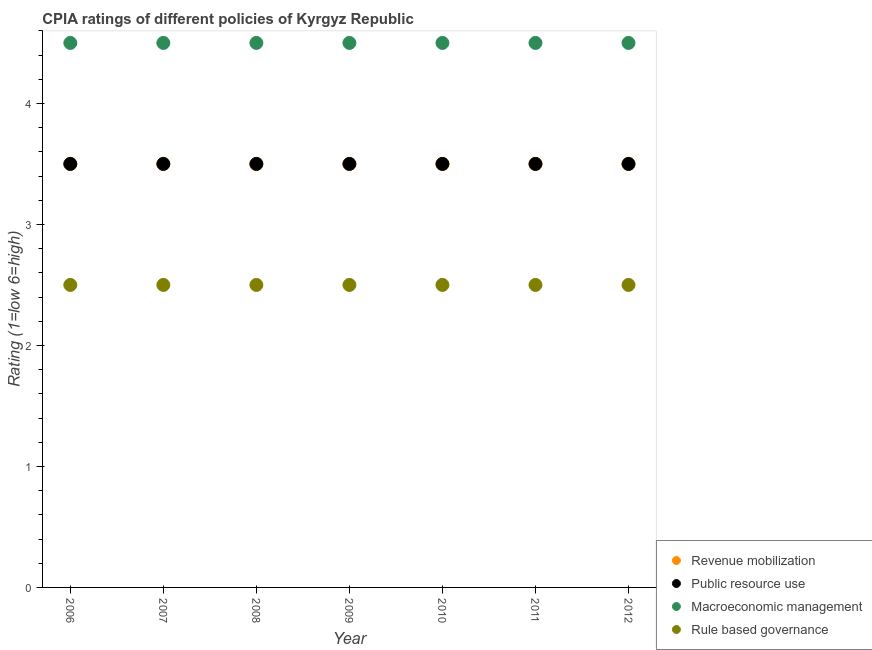How many different coloured dotlines are there?
Provide a short and direct response. 4. Is the number of dotlines equal to the number of legend labels?
Make the answer very short. Yes. Across all years, what is the maximum cpia rating of public resource use?
Offer a very short reply. 3.5. In which year was the cpia rating of public resource use minimum?
Your response must be concise. 2006. What is the total cpia rating of public resource use in the graph?
Keep it short and to the point. 24.5. What is the difference between the cpia rating of macroeconomic management in 2011 and that in 2012?
Provide a succinct answer. 0. What is the average cpia rating of macroeconomic management per year?
Keep it short and to the point. 4.5. In the year 2011, what is the difference between the cpia rating of public resource use and cpia rating of rule based governance?
Provide a succinct answer. 1. What is the ratio of the cpia rating of macroeconomic management in 2006 to that in 2011?
Provide a succinct answer. 1. Is the cpia rating of macroeconomic management in 2011 less than that in 2012?
Offer a very short reply. No. Is the sum of the cpia rating of revenue mobilization in 2008 and 2009 greater than the maximum cpia rating of macroeconomic management across all years?
Keep it short and to the point. Yes. Does the cpia rating of macroeconomic management monotonically increase over the years?
Your answer should be compact. No. Is the cpia rating of macroeconomic management strictly greater than the cpia rating of rule based governance over the years?
Give a very brief answer. Yes. Is the cpia rating of rule based governance strictly less than the cpia rating of revenue mobilization over the years?
Ensure brevity in your answer.  Yes. Are the values on the major ticks of Y-axis written in scientific E-notation?
Your response must be concise. No. Does the graph contain grids?
Your answer should be very brief. No. Where does the legend appear in the graph?
Provide a short and direct response. Bottom right. How many legend labels are there?
Offer a very short reply. 4. How are the legend labels stacked?
Give a very brief answer. Vertical. What is the title of the graph?
Offer a very short reply. CPIA ratings of different policies of Kyrgyz Republic. What is the Rating (1=low 6=high) of Revenue mobilization in 2006?
Your answer should be very brief. 3.5. What is the Rating (1=low 6=high) in Public resource use in 2006?
Offer a terse response. 3.5. What is the Rating (1=low 6=high) of Macroeconomic management in 2006?
Provide a short and direct response. 4.5. What is the Rating (1=low 6=high) in Revenue mobilization in 2007?
Offer a very short reply. 3.5. What is the Rating (1=low 6=high) of Public resource use in 2007?
Give a very brief answer. 3.5. What is the Rating (1=low 6=high) of Macroeconomic management in 2007?
Your answer should be compact. 4.5. What is the Rating (1=low 6=high) of Revenue mobilization in 2008?
Your answer should be compact. 3.5. What is the Rating (1=low 6=high) of Macroeconomic management in 2008?
Ensure brevity in your answer.  4.5. What is the Rating (1=low 6=high) in Public resource use in 2009?
Offer a very short reply. 3.5. What is the Rating (1=low 6=high) of Macroeconomic management in 2009?
Keep it short and to the point. 4.5. What is the Rating (1=low 6=high) of Public resource use in 2010?
Give a very brief answer. 3.5. What is the Rating (1=low 6=high) of Macroeconomic management in 2010?
Make the answer very short. 4.5. What is the Rating (1=low 6=high) in Revenue mobilization in 2011?
Ensure brevity in your answer.  3.5. What is the Rating (1=low 6=high) of Public resource use in 2011?
Make the answer very short. 3.5. What is the Rating (1=low 6=high) of Rule based governance in 2011?
Ensure brevity in your answer.  2.5. What is the Rating (1=low 6=high) of Revenue mobilization in 2012?
Ensure brevity in your answer.  3.5. What is the Rating (1=low 6=high) of Macroeconomic management in 2012?
Keep it short and to the point. 4.5. Across all years, what is the maximum Rating (1=low 6=high) of Revenue mobilization?
Offer a very short reply. 3.5. Across all years, what is the maximum Rating (1=low 6=high) in Macroeconomic management?
Offer a very short reply. 4.5. Across all years, what is the minimum Rating (1=low 6=high) of Revenue mobilization?
Your response must be concise. 3.5. Across all years, what is the minimum Rating (1=low 6=high) of Public resource use?
Your response must be concise. 3.5. What is the total Rating (1=low 6=high) of Revenue mobilization in the graph?
Provide a succinct answer. 24.5. What is the total Rating (1=low 6=high) of Public resource use in the graph?
Ensure brevity in your answer.  24.5. What is the total Rating (1=low 6=high) of Macroeconomic management in the graph?
Offer a terse response. 31.5. What is the difference between the Rating (1=low 6=high) of Macroeconomic management in 2006 and that in 2007?
Offer a terse response. 0. What is the difference between the Rating (1=low 6=high) in Revenue mobilization in 2006 and that in 2008?
Your response must be concise. 0. What is the difference between the Rating (1=low 6=high) of Public resource use in 2006 and that in 2008?
Your response must be concise. 0. What is the difference between the Rating (1=low 6=high) of Macroeconomic management in 2006 and that in 2008?
Provide a succinct answer. 0. What is the difference between the Rating (1=low 6=high) of Revenue mobilization in 2006 and that in 2009?
Your answer should be very brief. 0. What is the difference between the Rating (1=low 6=high) of Macroeconomic management in 2006 and that in 2009?
Make the answer very short. 0. What is the difference between the Rating (1=low 6=high) in Rule based governance in 2006 and that in 2009?
Offer a very short reply. 0. What is the difference between the Rating (1=low 6=high) of Macroeconomic management in 2006 and that in 2010?
Make the answer very short. 0. What is the difference between the Rating (1=low 6=high) of Rule based governance in 2006 and that in 2010?
Your response must be concise. 0. What is the difference between the Rating (1=low 6=high) of Revenue mobilization in 2006 and that in 2011?
Offer a very short reply. 0. What is the difference between the Rating (1=low 6=high) of Public resource use in 2006 and that in 2011?
Offer a very short reply. 0. What is the difference between the Rating (1=low 6=high) of Macroeconomic management in 2006 and that in 2011?
Make the answer very short. 0. What is the difference between the Rating (1=low 6=high) of Rule based governance in 2006 and that in 2011?
Your answer should be very brief. 0. What is the difference between the Rating (1=low 6=high) in Revenue mobilization in 2006 and that in 2012?
Your answer should be compact. 0. What is the difference between the Rating (1=low 6=high) in Macroeconomic management in 2006 and that in 2012?
Your answer should be compact. 0. What is the difference between the Rating (1=low 6=high) in Rule based governance in 2006 and that in 2012?
Offer a very short reply. 0. What is the difference between the Rating (1=low 6=high) of Public resource use in 2007 and that in 2008?
Your answer should be very brief. 0. What is the difference between the Rating (1=low 6=high) in Macroeconomic management in 2007 and that in 2008?
Your answer should be very brief. 0. What is the difference between the Rating (1=low 6=high) in Rule based governance in 2007 and that in 2008?
Your answer should be very brief. 0. What is the difference between the Rating (1=low 6=high) of Revenue mobilization in 2007 and that in 2009?
Provide a succinct answer. 0. What is the difference between the Rating (1=low 6=high) of Macroeconomic management in 2007 and that in 2009?
Offer a terse response. 0. What is the difference between the Rating (1=low 6=high) of Macroeconomic management in 2007 and that in 2010?
Your response must be concise. 0. What is the difference between the Rating (1=low 6=high) in Rule based governance in 2007 and that in 2010?
Provide a succinct answer. 0. What is the difference between the Rating (1=low 6=high) in Revenue mobilization in 2007 and that in 2011?
Offer a very short reply. 0. What is the difference between the Rating (1=low 6=high) in Rule based governance in 2007 and that in 2011?
Your answer should be compact. 0. What is the difference between the Rating (1=low 6=high) in Rule based governance in 2007 and that in 2012?
Give a very brief answer. 0. What is the difference between the Rating (1=low 6=high) of Revenue mobilization in 2008 and that in 2009?
Offer a terse response. 0. What is the difference between the Rating (1=low 6=high) of Macroeconomic management in 2008 and that in 2009?
Your response must be concise. 0. What is the difference between the Rating (1=low 6=high) of Public resource use in 2008 and that in 2010?
Make the answer very short. 0. What is the difference between the Rating (1=low 6=high) of Revenue mobilization in 2008 and that in 2011?
Offer a terse response. 0. What is the difference between the Rating (1=low 6=high) of Rule based governance in 2008 and that in 2011?
Provide a short and direct response. 0. What is the difference between the Rating (1=low 6=high) in Revenue mobilization in 2008 and that in 2012?
Offer a very short reply. 0. What is the difference between the Rating (1=low 6=high) of Public resource use in 2008 and that in 2012?
Provide a succinct answer. 0. What is the difference between the Rating (1=low 6=high) in Macroeconomic management in 2008 and that in 2012?
Ensure brevity in your answer.  0. What is the difference between the Rating (1=low 6=high) in Rule based governance in 2008 and that in 2012?
Offer a very short reply. 0. What is the difference between the Rating (1=low 6=high) of Revenue mobilization in 2009 and that in 2011?
Offer a terse response. 0. What is the difference between the Rating (1=low 6=high) of Public resource use in 2009 and that in 2011?
Provide a short and direct response. 0. What is the difference between the Rating (1=low 6=high) of Rule based governance in 2009 and that in 2011?
Your answer should be very brief. 0. What is the difference between the Rating (1=low 6=high) in Public resource use in 2009 and that in 2012?
Your answer should be compact. 0. What is the difference between the Rating (1=low 6=high) in Rule based governance in 2009 and that in 2012?
Give a very brief answer. 0. What is the difference between the Rating (1=low 6=high) in Revenue mobilization in 2010 and that in 2011?
Ensure brevity in your answer.  0. What is the difference between the Rating (1=low 6=high) in Public resource use in 2010 and that in 2011?
Provide a short and direct response. 0. What is the difference between the Rating (1=low 6=high) of Rule based governance in 2010 and that in 2011?
Provide a succinct answer. 0. What is the difference between the Rating (1=low 6=high) in Revenue mobilization in 2010 and that in 2012?
Offer a very short reply. 0. What is the difference between the Rating (1=low 6=high) in Public resource use in 2010 and that in 2012?
Offer a terse response. 0. What is the difference between the Rating (1=low 6=high) in Macroeconomic management in 2010 and that in 2012?
Keep it short and to the point. 0. What is the difference between the Rating (1=low 6=high) of Revenue mobilization in 2011 and that in 2012?
Offer a very short reply. 0. What is the difference between the Rating (1=low 6=high) of Public resource use in 2011 and that in 2012?
Your answer should be compact. 0. What is the difference between the Rating (1=low 6=high) in Rule based governance in 2011 and that in 2012?
Your answer should be compact. 0. What is the difference between the Rating (1=low 6=high) of Revenue mobilization in 2006 and the Rating (1=low 6=high) of Public resource use in 2007?
Provide a short and direct response. 0. What is the difference between the Rating (1=low 6=high) in Revenue mobilization in 2006 and the Rating (1=low 6=high) in Macroeconomic management in 2007?
Keep it short and to the point. -1. What is the difference between the Rating (1=low 6=high) of Public resource use in 2006 and the Rating (1=low 6=high) of Rule based governance in 2007?
Your answer should be compact. 1. What is the difference between the Rating (1=low 6=high) of Revenue mobilization in 2006 and the Rating (1=low 6=high) of Public resource use in 2008?
Your answer should be compact. 0. What is the difference between the Rating (1=low 6=high) of Revenue mobilization in 2006 and the Rating (1=low 6=high) of Macroeconomic management in 2008?
Make the answer very short. -1. What is the difference between the Rating (1=low 6=high) in Revenue mobilization in 2006 and the Rating (1=low 6=high) in Rule based governance in 2008?
Your answer should be very brief. 1. What is the difference between the Rating (1=low 6=high) in Public resource use in 2006 and the Rating (1=low 6=high) in Macroeconomic management in 2008?
Keep it short and to the point. -1. What is the difference between the Rating (1=low 6=high) in Public resource use in 2006 and the Rating (1=low 6=high) in Rule based governance in 2008?
Your answer should be very brief. 1. What is the difference between the Rating (1=low 6=high) in Revenue mobilization in 2006 and the Rating (1=low 6=high) in Rule based governance in 2009?
Offer a terse response. 1. What is the difference between the Rating (1=low 6=high) in Public resource use in 2006 and the Rating (1=low 6=high) in Macroeconomic management in 2009?
Offer a terse response. -1. What is the difference between the Rating (1=low 6=high) of Macroeconomic management in 2006 and the Rating (1=low 6=high) of Rule based governance in 2009?
Your answer should be very brief. 2. What is the difference between the Rating (1=low 6=high) of Revenue mobilization in 2006 and the Rating (1=low 6=high) of Public resource use in 2010?
Make the answer very short. 0. What is the difference between the Rating (1=low 6=high) of Revenue mobilization in 2006 and the Rating (1=low 6=high) of Rule based governance in 2010?
Make the answer very short. 1. What is the difference between the Rating (1=low 6=high) in Macroeconomic management in 2006 and the Rating (1=low 6=high) in Rule based governance in 2010?
Provide a succinct answer. 2. What is the difference between the Rating (1=low 6=high) of Revenue mobilization in 2006 and the Rating (1=low 6=high) of Public resource use in 2011?
Your answer should be compact. 0. What is the difference between the Rating (1=low 6=high) of Revenue mobilization in 2006 and the Rating (1=low 6=high) of Macroeconomic management in 2011?
Make the answer very short. -1. What is the difference between the Rating (1=low 6=high) in Revenue mobilization in 2006 and the Rating (1=low 6=high) in Rule based governance in 2011?
Your response must be concise. 1. What is the difference between the Rating (1=low 6=high) in Public resource use in 2006 and the Rating (1=low 6=high) in Macroeconomic management in 2011?
Give a very brief answer. -1. What is the difference between the Rating (1=low 6=high) in Revenue mobilization in 2006 and the Rating (1=low 6=high) in Public resource use in 2012?
Provide a short and direct response. 0. What is the difference between the Rating (1=low 6=high) of Revenue mobilization in 2006 and the Rating (1=low 6=high) of Macroeconomic management in 2012?
Ensure brevity in your answer.  -1. What is the difference between the Rating (1=low 6=high) in Revenue mobilization in 2006 and the Rating (1=low 6=high) in Rule based governance in 2012?
Your answer should be compact. 1. What is the difference between the Rating (1=low 6=high) in Revenue mobilization in 2007 and the Rating (1=low 6=high) in Rule based governance in 2008?
Make the answer very short. 1. What is the difference between the Rating (1=low 6=high) in Public resource use in 2007 and the Rating (1=low 6=high) in Rule based governance in 2008?
Make the answer very short. 1. What is the difference between the Rating (1=low 6=high) of Macroeconomic management in 2007 and the Rating (1=low 6=high) of Rule based governance in 2008?
Your answer should be very brief. 2. What is the difference between the Rating (1=low 6=high) of Revenue mobilization in 2007 and the Rating (1=low 6=high) of Macroeconomic management in 2009?
Offer a very short reply. -1. What is the difference between the Rating (1=low 6=high) of Public resource use in 2007 and the Rating (1=low 6=high) of Rule based governance in 2009?
Offer a very short reply. 1. What is the difference between the Rating (1=low 6=high) in Macroeconomic management in 2007 and the Rating (1=low 6=high) in Rule based governance in 2009?
Your answer should be compact. 2. What is the difference between the Rating (1=low 6=high) of Revenue mobilization in 2007 and the Rating (1=low 6=high) of Macroeconomic management in 2010?
Ensure brevity in your answer.  -1. What is the difference between the Rating (1=low 6=high) in Public resource use in 2007 and the Rating (1=low 6=high) in Macroeconomic management in 2010?
Make the answer very short. -1. What is the difference between the Rating (1=low 6=high) of Revenue mobilization in 2007 and the Rating (1=low 6=high) of Macroeconomic management in 2011?
Keep it short and to the point. -1. What is the difference between the Rating (1=low 6=high) in Revenue mobilization in 2007 and the Rating (1=low 6=high) in Rule based governance in 2011?
Provide a succinct answer. 1. What is the difference between the Rating (1=low 6=high) of Public resource use in 2007 and the Rating (1=low 6=high) of Macroeconomic management in 2011?
Offer a very short reply. -1. What is the difference between the Rating (1=low 6=high) in Revenue mobilization in 2007 and the Rating (1=low 6=high) in Macroeconomic management in 2012?
Your answer should be very brief. -1. What is the difference between the Rating (1=low 6=high) in Revenue mobilization in 2007 and the Rating (1=low 6=high) in Rule based governance in 2012?
Provide a short and direct response. 1. What is the difference between the Rating (1=low 6=high) of Public resource use in 2007 and the Rating (1=low 6=high) of Macroeconomic management in 2012?
Offer a very short reply. -1. What is the difference between the Rating (1=low 6=high) in Revenue mobilization in 2008 and the Rating (1=low 6=high) in Rule based governance in 2009?
Make the answer very short. 1. What is the difference between the Rating (1=low 6=high) in Revenue mobilization in 2008 and the Rating (1=low 6=high) in Macroeconomic management in 2010?
Make the answer very short. -1. What is the difference between the Rating (1=low 6=high) in Public resource use in 2008 and the Rating (1=low 6=high) in Macroeconomic management in 2010?
Offer a terse response. -1. What is the difference between the Rating (1=low 6=high) in Macroeconomic management in 2008 and the Rating (1=low 6=high) in Rule based governance in 2010?
Offer a terse response. 2. What is the difference between the Rating (1=low 6=high) of Revenue mobilization in 2008 and the Rating (1=low 6=high) of Public resource use in 2011?
Ensure brevity in your answer.  0. What is the difference between the Rating (1=low 6=high) in Public resource use in 2008 and the Rating (1=low 6=high) in Macroeconomic management in 2011?
Give a very brief answer. -1. What is the difference between the Rating (1=low 6=high) in Public resource use in 2008 and the Rating (1=low 6=high) in Rule based governance in 2011?
Your answer should be very brief. 1. What is the difference between the Rating (1=low 6=high) of Revenue mobilization in 2008 and the Rating (1=low 6=high) of Macroeconomic management in 2012?
Your answer should be very brief. -1. What is the difference between the Rating (1=low 6=high) in Public resource use in 2008 and the Rating (1=low 6=high) in Macroeconomic management in 2012?
Offer a terse response. -1. What is the difference between the Rating (1=low 6=high) in Public resource use in 2008 and the Rating (1=low 6=high) in Rule based governance in 2012?
Your answer should be compact. 1. What is the difference between the Rating (1=low 6=high) in Public resource use in 2009 and the Rating (1=low 6=high) in Macroeconomic management in 2010?
Your answer should be very brief. -1. What is the difference between the Rating (1=low 6=high) in Public resource use in 2009 and the Rating (1=low 6=high) in Rule based governance in 2010?
Offer a very short reply. 1. What is the difference between the Rating (1=low 6=high) of Macroeconomic management in 2009 and the Rating (1=low 6=high) of Rule based governance in 2010?
Keep it short and to the point. 2. What is the difference between the Rating (1=low 6=high) in Revenue mobilization in 2009 and the Rating (1=low 6=high) in Macroeconomic management in 2011?
Ensure brevity in your answer.  -1. What is the difference between the Rating (1=low 6=high) in Macroeconomic management in 2009 and the Rating (1=low 6=high) in Rule based governance in 2011?
Give a very brief answer. 2. What is the difference between the Rating (1=low 6=high) of Revenue mobilization in 2009 and the Rating (1=low 6=high) of Macroeconomic management in 2012?
Your response must be concise. -1. What is the difference between the Rating (1=low 6=high) in Revenue mobilization in 2009 and the Rating (1=low 6=high) in Rule based governance in 2012?
Offer a very short reply. 1. What is the difference between the Rating (1=low 6=high) of Public resource use in 2009 and the Rating (1=low 6=high) of Macroeconomic management in 2012?
Ensure brevity in your answer.  -1. What is the difference between the Rating (1=low 6=high) in Public resource use in 2009 and the Rating (1=low 6=high) in Rule based governance in 2012?
Provide a short and direct response. 1. What is the difference between the Rating (1=low 6=high) of Revenue mobilization in 2010 and the Rating (1=low 6=high) of Public resource use in 2011?
Keep it short and to the point. 0. What is the difference between the Rating (1=low 6=high) in Revenue mobilization in 2010 and the Rating (1=low 6=high) in Macroeconomic management in 2011?
Make the answer very short. -1. What is the difference between the Rating (1=low 6=high) in Macroeconomic management in 2010 and the Rating (1=low 6=high) in Rule based governance in 2011?
Offer a very short reply. 2. What is the difference between the Rating (1=low 6=high) in Revenue mobilization in 2010 and the Rating (1=low 6=high) in Macroeconomic management in 2012?
Make the answer very short. -1. What is the difference between the Rating (1=low 6=high) in Revenue mobilization in 2010 and the Rating (1=low 6=high) in Rule based governance in 2012?
Ensure brevity in your answer.  1. What is the difference between the Rating (1=low 6=high) in Public resource use in 2010 and the Rating (1=low 6=high) in Rule based governance in 2012?
Provide a succinct answer. 1. What is the difference between the Rating (1=low 6=high) of Macroeconomic management in 2010 and the Rating (1=low 6=high) of Rule based governance in 2012?
Make the answer very short. 2. What is the difference between the Rating (1=low 6=high) in Revenue mobilization in 2011 and the Rating (1=low 6=high) in Public resource use in 2012?
Your response must be concise. 0. What is the difference between the Rating (1=low 6=high) in Public resource use in 2011 and the Rating (1=low 6=high) in Rule based governance in 2012?
Give a very brief answer. 1. What is the average Rating (1=low 6=high) of Revenue mobilization per year?
Offer a terse response. 3.5. In the year 2006, what is the difference between the Rating (1=low 6=high) of Revenue mobilization and Rating (1=low 6=high) of Public resource use?
Keep it short and to the point. 0. In the year 2006, what is the difference between the Rating (1=low 6=high) of Public resource use and Rating (1=low 6=high) of Rule based governance?
Offer a very short reply. 1. In the year 2006, what is the difference between the Rating (1=low 6=high) in Macroeconomic management and Rating (1=low 6=high) in Rule based governance?
Ensure brevity in your answer.  2. In the year 2007, what is the difference between the Rating (1=low 6=high) of Revenue mobilization and Rating (1=low 6=high) of Public resource use?
Provide a short and direct response. 0. In the year 2007, what is the difference between the Rating (1=low 6=high) in Public resource use and Rating (1=low 6=high) in Rule based governance?
Make the answer very short. 1. In the year 2008, what is the difference between the Rating (1=low 6=high) of Revenue mobilization and Rating (1=low 6=high) of Public resource use?
Your answer should be compact. 0. In the year 2008, what is the difference between the Rating (1=low 6=high) in Revenue mobilization and Rating (1=low 6=high) in Macroeconomic management?
Offer a very short reply. -1. In the year 2008, what is the difference between the Rating (1=low 6=high) in Revenue mobilization and Rating (1=low 6=high) in Rule based governance?
Keep it short and to the point. 1. In the year 2009, what is the difference between the Rating (1=low 6=high) in Revenue mobilization and Rating (1=low 6=high) in Macroeconomic management?
Offer a terse response. -1. In the year 2009, what is the difference between the Rating (1=low 6=high) of Revenue mobilization and Rating (1=low 6=high) of Rule based governance?
Provide a short and direct response. 1. In the year 2009, what is the difference between the Rating (1=low 6=high) of Macroeconomic management and Rating (1=low 6=high) of Rule based governance?
Provide a succinct answer. 2. In the year 2010, what is the difference between the Rating (1=low 6=high) in Revenue mobilization and Rating (1=low 6=high) in Macroeconomic management?
Offer a terse response. -1. In the year 2010, what is the difference between the Rating (1=low 6=high) of Revenue mobilization and Rating (1=low 6=high) of Rule based governance?
Offer a very short reply. 1. In the year 2010, what is the difference between the Rating (1=low 6=high) of Public resource use and Rating (1=low 6=high) of Macroeconomic management?
Your answer should be very brief. -1. In the year 2010, what is the difference between the Rating (1=low 6=high) of Public resource use and Rating (1=low 6=high) of Rule based governance?
Your response must be concise. 1. In the year 2011, what is the difference between the Rating (1=low 6=high) of Revenue mobilization and Rating (1=low 6=high) of Macroeconomic management?
Keep it short and to the point. -1. In the year 2011, what is the difference between the Rating (1=low 6=high) in Revenue mobilization and Rating (1=low 6=high) in Rule based governance?
Keep it short and to the point. 1. In the year 2011, what is the difference between the Rating (1=low 6=high) in Public resource use and Rating (1=low 6=high) in Macroeconomic management?
Your response must be concise. -1. In the year 2012, what is the difference between the Rating (1=low 6=high) of Macroeconomic management and Rating (1=low 6=high) of Rule based governance?
Provide a short and direct response. 2. What is the ratio of the Rating (1=low 6=high) of Revenue mobilization in 2006 to that in 2007?
Offer a very short reply. 1. What is the ratio of the Rating (1=low 6=high) in Macroeconomic management in 2006 to that in 2007?
Make the answer very short. 1. What is the ratio of the Rating (1=low 6=high) of Rule based governance in 2006 to that in 2007?
Provide a succinct answer. 1. What is the ratio of the Rating (1=low 6=high) of Public resource use in 2006 to that in 2008?
Give a very brief answer. 1. What is the ratio of the Rating (1=low 6=high) of Rule based governance in 2006 to that in 2008?
Make the answer very short. 1. What is the ratio of the Rating (1=low 6=high) of Revenue mobilization in 2006 to that in 2010?
Provide a succinct answer. 1. What is the ratio of the Rating (1=low 6=high) in Public resource use in 2006 to that in 2010?
Your response must be concise. 1. What is the ratio of the Rating (1=low 6=high) in Macroeconomic management in 2006 to that in 2010?
Provide a short and direct response. 1. What is the ratio of the Rating (1=low 6=high) of Rule based governance in 2006 to that in 2010?
Your answer should be compact. 1. What is the ratio of the Rating (1=low 6=high) of Public resource use in 2006 to that in 2011?
Offer a very short reply. 1. What is the ratio of the Rating (1=low 6=high) of Revenue mobilization in 2006 to that in 2012?
Provide a short and direct response. 1. What is the ratio of the Rating (1=low 6=high) of Macroeconomic management in 2006 to that in 2012?
Provide a short and direct response. 1. What is the ratio of the Rating (1=low 6=high) of Revenue mobilization in 2007 to that in 2009?
Provide a succinct answer. 1. What is the ratio of the Rating (1=low 6=high) of Public resource use in 2007 to that in 2009?
Offer a very short reply. 1. What is the ratio of the Rating (1=low 6=high) of Rule based governance in 2007 to that in 2009?
Your answer should be compact. 1. What is the ratio of the Rating (1=low 6=high) in Revenue mobilization in 2007 to that in 2010?
Provide a succinct answer. 1. What is the ratio of the Rating (1=low 6=high) of Public resource use in 2007 to that in 2010?
Make the answer very short. 1. What is the ratio of the Rating (1=low 6=high) of Revenue mobilization in 2007 to that in 2011?
Provide a short and direct response. 1. What is the ratio of the Rating (1=low 6=high) in Public resource use in 2007 to that in 2011?
Your answer should be compact. 1. What is the ratio of the Rating (1=low 6=high) of Rule based governance in 2007 to that in 2011?
Offer a very short reply. 1. What is the ratio of the Rating (1=low 6=high) in Revenue mobilization in 2007 to that in 2012?
Keep it short and to the point. 1. What is the ratio of the Rating (1=low 6=high) of Revenue mobilization in 2008 to that in 2009?
Provide a succinct answer. 1. What is the ratio of the Rating (1=low 6=high) in Public resource use in 2008 to that in 2009?
Ensure brevity in your answer.  1. What is the ratio of the Rating (1=low 6=high) of Macroeconomic management in 2008 to that in 2009?
Provide a short and direct response. 1. What is the ratio of the Rating (1=low 6=high) of Public resource use in 2008 to that in 2010?
Your answer should be compact. 1. What is the ratio of the Rating (1=low 6=high) of Macroeconomic management in 2008 to that in 2010?
Make the answer very short. 1. What is the ratio of the Rating (1=low 6=high) in Rule based governance in 2008 to that in 2010?
Provide a short and direct response. 1. What is the ratio of the Rating (1=low 6=high) of Revenue mobilization in 2008 to that in 2011?
Provide a short and direct response. 1. What is the ratio of the Rating (1=low 6=high) of Macroeconomic management in 2008 to that in 2011?
Offer a terse response. 1. What is the ratio of the Rating (1=low 6=high) of Rule based governance in 2008 to that in 2011?
Ensure brevity in your answer.  1. What is the ratio of the Rating (1=low 6=high) in Public resource use in 2008 to that in 2012?
Offer a terse response. 1. What is the ratio of the Rating (1=low 6=high) in Rule based governance in 2008 to that in 2012?
Offer a terse response. 1. What is the ratio of the Rating (1=low 6=high) of Macroeconomic management in 2009 to that in 2011?
Your answer should be very brief. 1. What is the ratio of the Rating (1=low 6=high) of Rule based governance in 2009 to that in 2011?
Keep it short and to the point. 1. What is the ratio of the Rating (1=low 6=high) in Macroeconomic management in 2009 to that in 2012?
Your answer should be very brief. 1. What is the ratio of the Rating (1=low 6=high) of Rule based governance in 2009 to that in 2012?
Offer a very short reply. 1. What is the ratio of the Rating (1=low 6=high) in Public resource use in 2010 to that in 2011?
Give a very brief answer. 1. What is the ratio of the Rating (1=low 6=high) in Macroeconomic management in 2010 to that in 2011?
Your answer should be very brief. 1. What is the ratio of the Rating (1=low 6=high) in Revenue mobilization in 2010 to that in 2012?
Your response must be concise. 1. What is the ratio of the Rating (1=low 6=high) of Public resource use in 2010 to that in 2012?
Provide a short and direct response. 1. What is the ratio of the Rating (1=low 6=high) of Macroeconomic management in 2010 to that in 2012?
Your answer should be very brief. 1. What is the ratio of the Rating (1=low 6=high) of Rule based governance in 2010 to that in 2012?
Your response must be concise. 1. What is the ratio of the Rating (1=low 6=high) in Revenue mobilization in 2011 to that in 2012?
Your answer should be compact. 1. What is the ratio of the Rating (1=low 6=high) in Rule based governance in 2011 to that in 2012?
Your answer should be very brief. 1. What is the difference between the highest and the second highest Rating (1=low 6=high) in Revenue mobilization?
Give a very brief answer. 0. What is the difference between the highest and the second highest Rating (1=low 6=high) in Public resource use?
Your answer should be very brief. 0. What is the difference between the highest and the second highest Rating (1=low 6=high) in Macroeconomic management?
Offer a very short reply. 0. What is the difference between the highest and the lowest Rating (1=low 6=high) of Public resource use?
Your response must be concise. 0. 